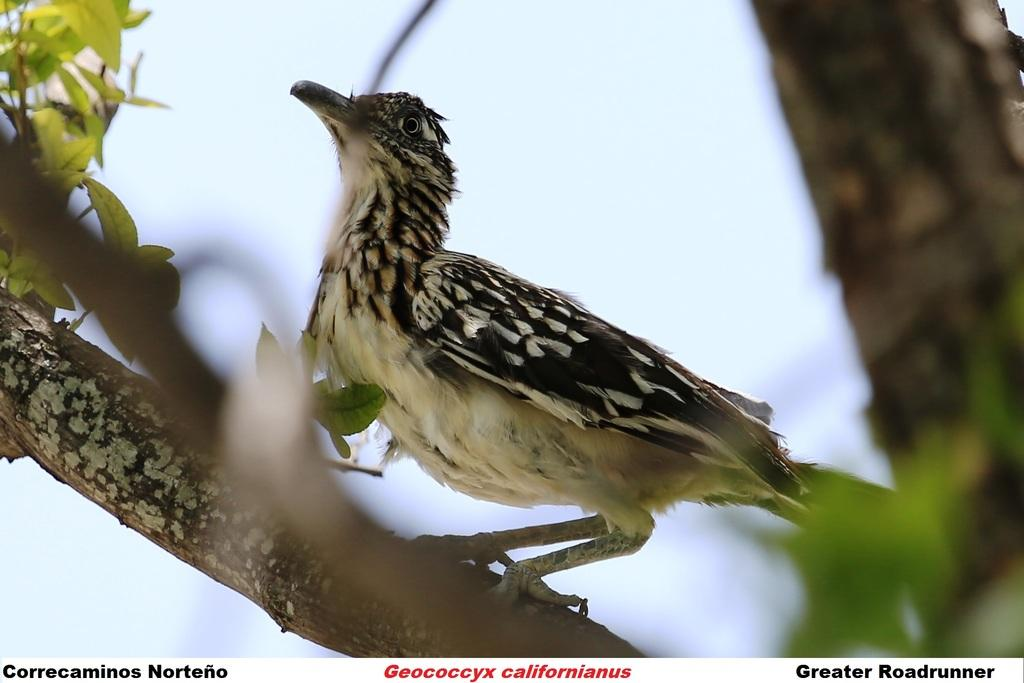What type of animal can be seen in the image? There is a bird in the image. Where is the bird located? The bird is on a branch. What type of vegetation is present in the image? There are green leaves in the image. What colors can be seen on the bird? The bird has a cream and black color. What is the color of the sky in the image? The sky is blue and white in color. What type of meat is hanging from the branch in the image? There is no meat present in the image; it features a bird on a branch. What shape is the mint taking in the image? There is no mint present in the image. 